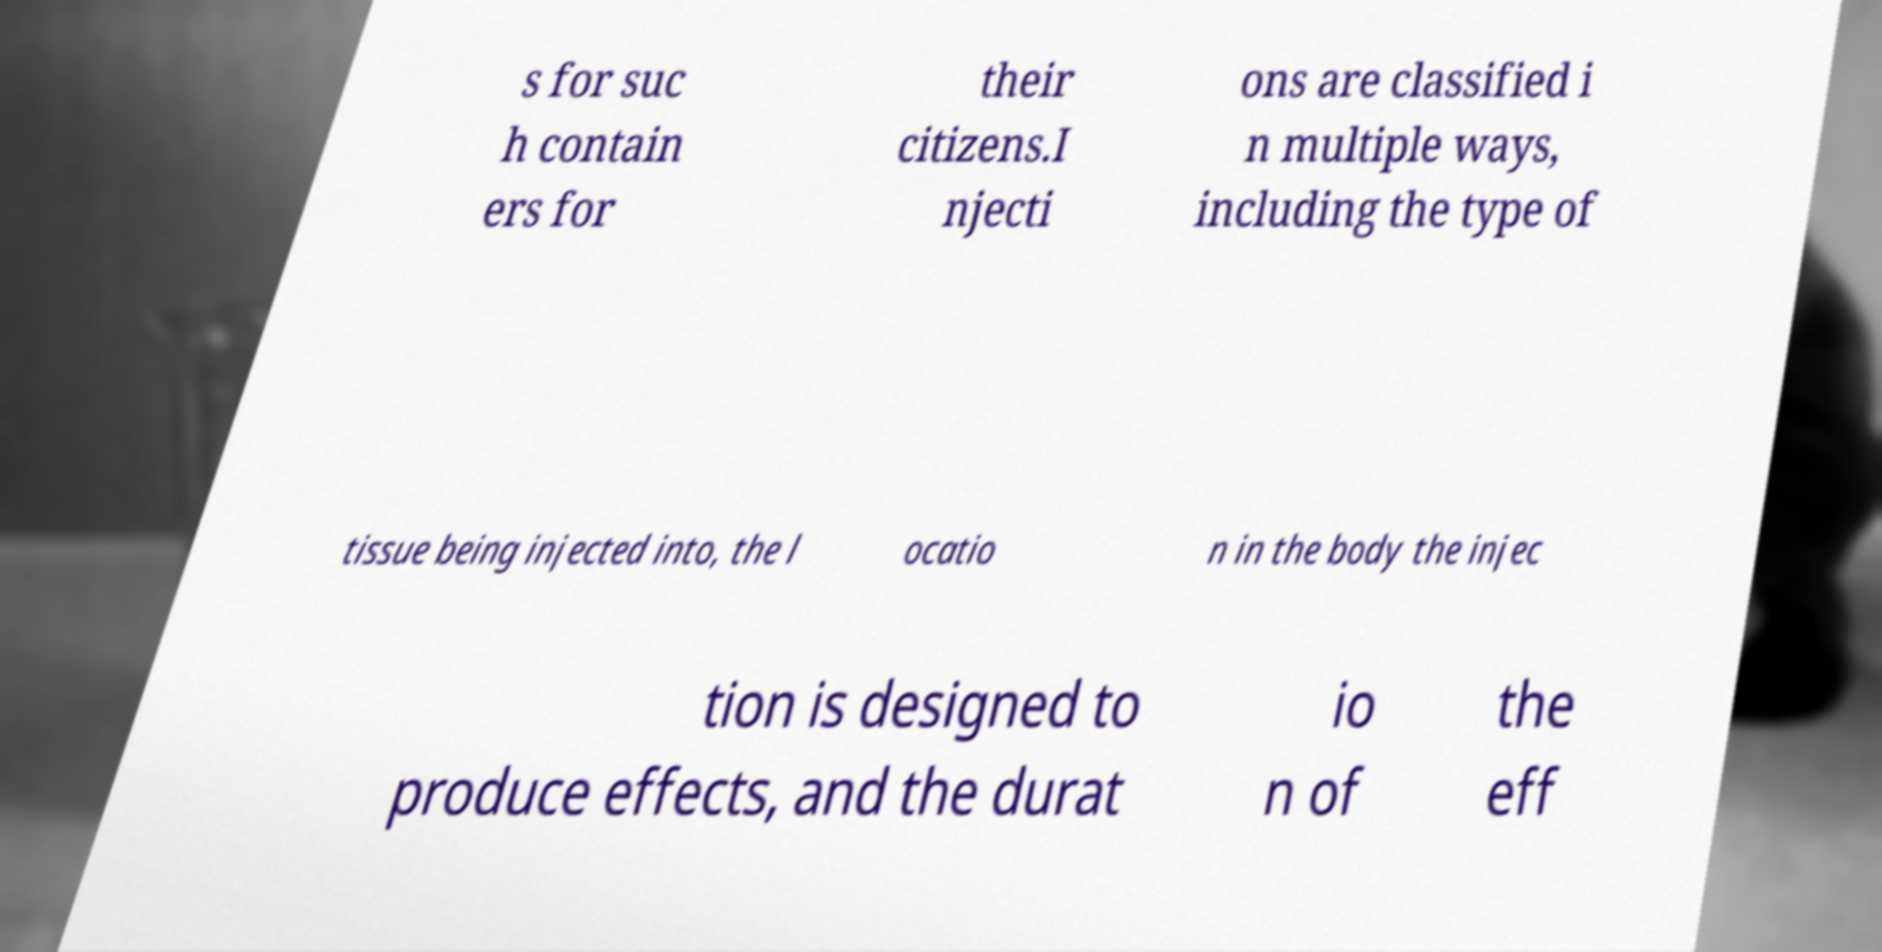Can you accurately transcribe the text from the provided image for me? s for suc h contain ers for their citizens.I njecti ons are classified i n multiple ways, including the type of tissue being injected into, the l ocatio n in the body the injec tion is designed to produce effects, and the durat io n of the eff 